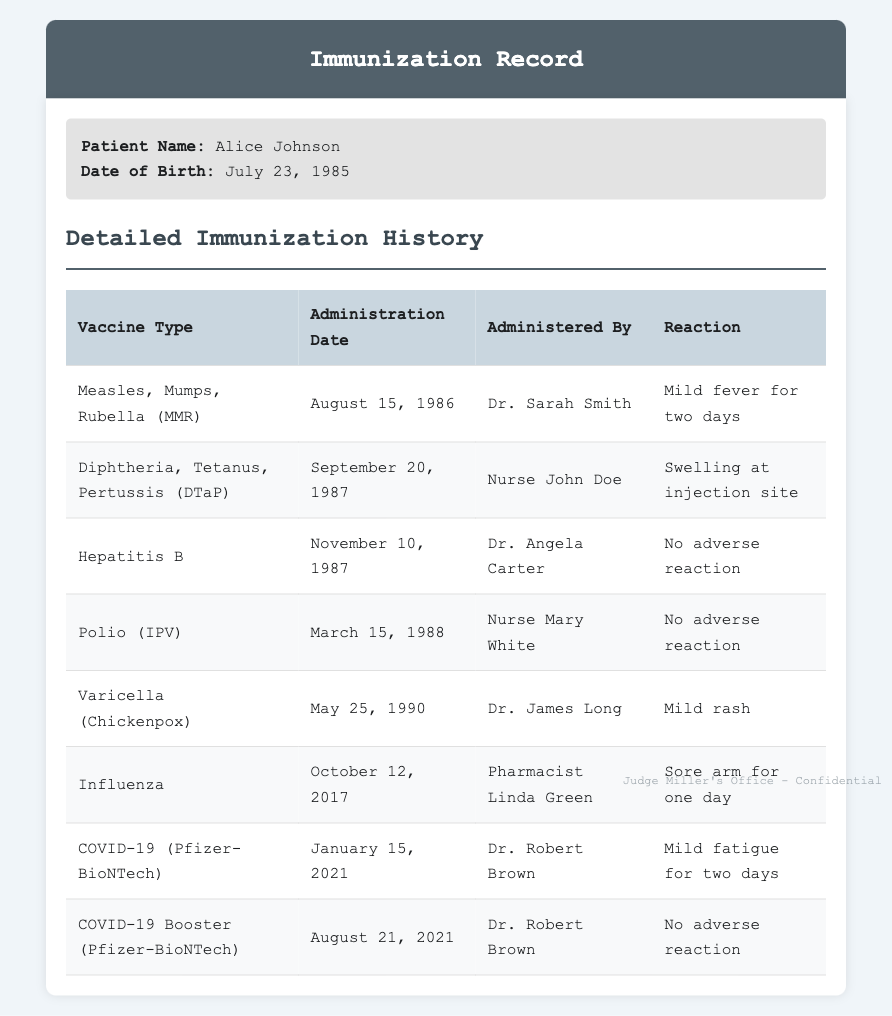What is the name of the patient? The name of the patient is located at the top of the document under patient information.
Answer: Alice Johnson What vaccine was administered on August 15, 1986? The vaccine administration date can be matched with the vaccine type in the table under detailed immunization history.
Answer: Measles, Mumps, Rubella (MMR) Who administered the Hepatitis B vaccine? The person who administered the Hepatitis B vaccine is noted in the same row in the table as the vaccine type and administration date.
Answer: Dr. Angela Carter What reaction was recorded for the COVID-19 vaccine? The recorded reaction for the COVID-19 vaccine appears in the corresponding row of the immunization history table.
Answer: Mild fatigue for two days How many vaccines were administered prior to 1990? Counting the number of vaccines listed in the table before the year 1990 will provide the answer.
Answer: Five What type of vaccine was given on October 12, 2017? The type of vaccine can be found by locating the administration date within the detailed immunization history table.
Answer: Influenza What reaction followed the Diphtheria, Tetanus, Pertussis vaccine? The reaction is detailed in the table next to the Diphtheria, Tetanus, Pertussis vaccine entry.
Answer: Swelling at injection site When was the second COVID-19 vaccine administered? This question can be answered by finding the specific date associated with the second COVID-19 vaccine entry in the table.
Answer: August 21, 2021 